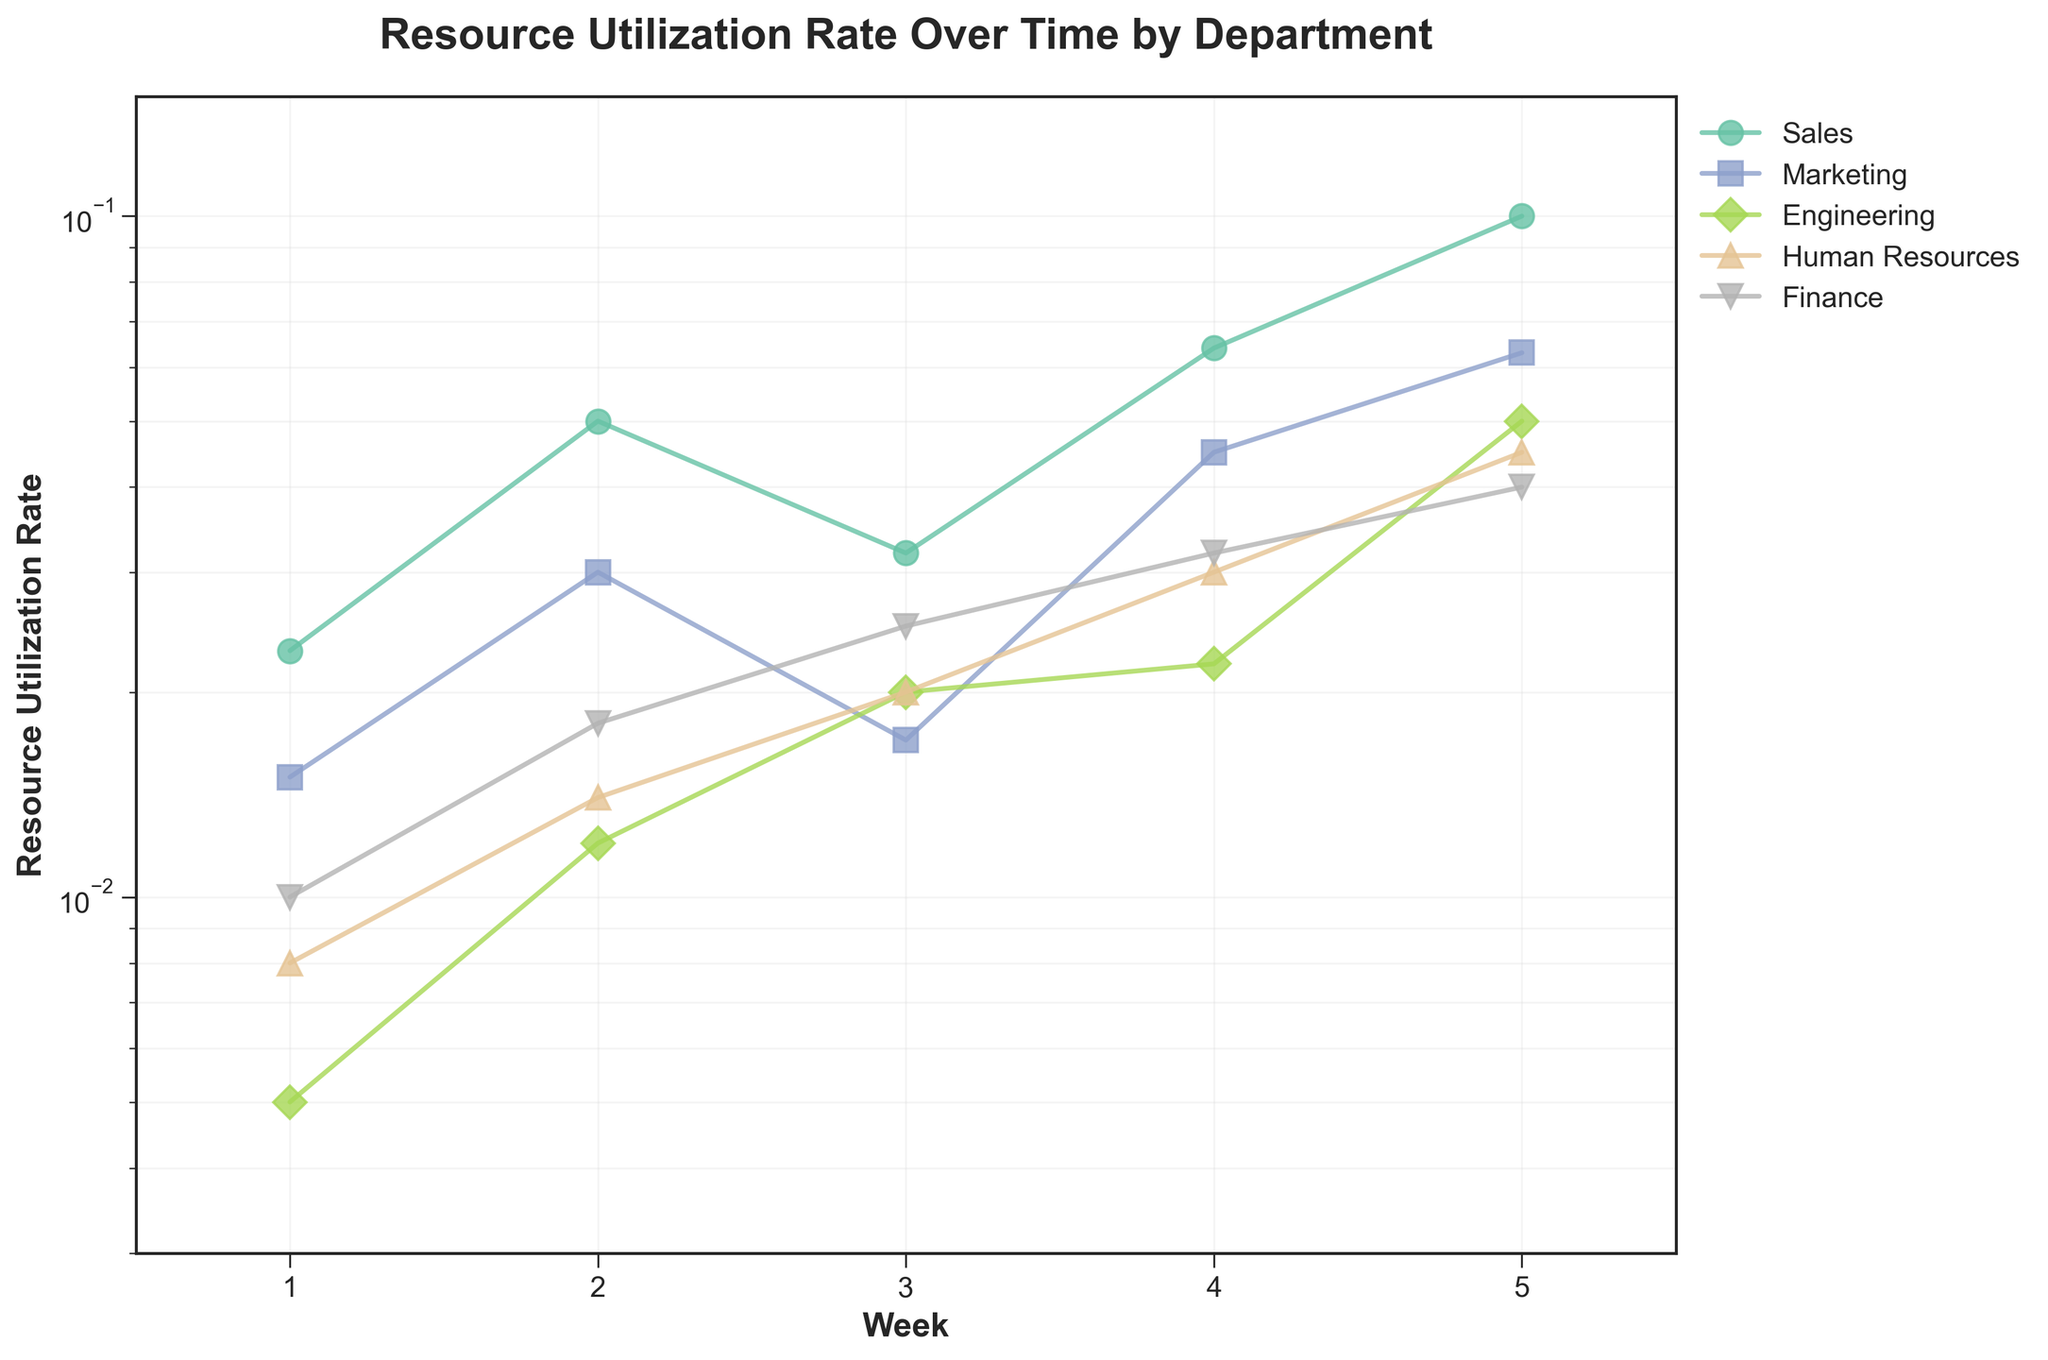Who has the highest resource utilization rate in week 4? To find the department with the highest utilization rate in week 4, look at the data points for week 4 across all departments. The Sales department has the highest rate at 0.064.
Answer: Sales What is the rate of increase in resource utilization for the Engineering department from week 3 to week 5? Calculate the difference in utilization rates for Engineering between week 5 and week 3. Rate at week 5 is 0.050, and rate at week 3 is 0.020. The increase is 0.050 - 0.020 = 0.030.
Answer: 0.030 Which department had the lowest resource utilization rate in week 1? Identify the data points for week 1 for all departments. Engineering has the lowest utilization rate at 0.005 in week 1.
Answer: Engineering How does the distribution of resource utilization rates change over time for Human Resources? Observe the trend for Human Resources across the weeks. HR starts at 0.008 and increases gradually to 0.045, indicating a steady increase in utilization rate over time.
Answer: Steady increase What's the difference between the highest and lowest resource utilization rate in week 2? Find the highest and lowest rates for week 2. The highest rate is Sales at 0.050 and the lowest is Engineering at 0.012. The difference is 0.050 - 0.012 = 0.038.
Answer: 0.038 Which department has the most consistent resource utilization rate over the 5 weeks? Evaluate the changes in the plots for each department. Finance increases steadily each week, showing a consistent trend.
Answer: Finance Are there any departments whose resource utilization rate dipped at some point before increasing again? Inspect the plotted lines for changes. Marketing's utilization rate drops from 0.030 in week 2 to 0.017 in week 3, then rises to 0.045 in week 4.
Answer: Marketing 